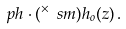<formula> <loc_0><loc_0><loc_500><loc_500>\ p h \cdot ( ^ { \times } \ s m ) h _ { o } ( z ) \, .</formula> 